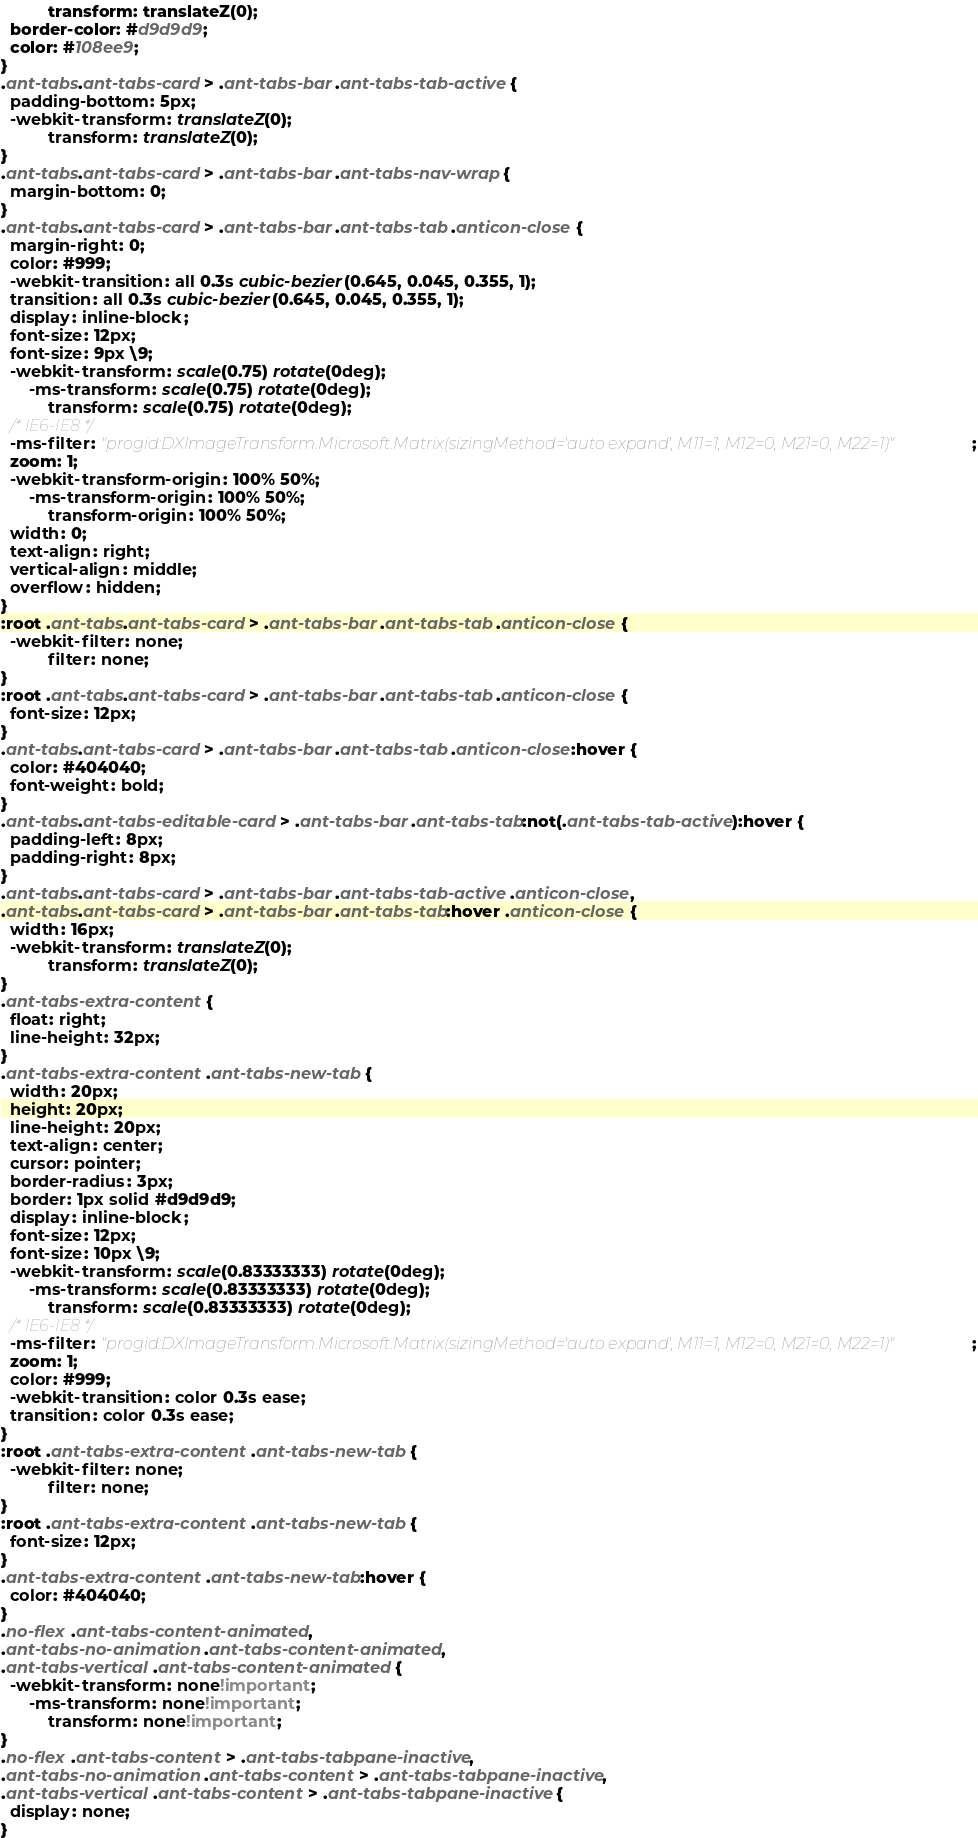Convert code to text. <code><loc_0><loc_0><loc_500><loc_500><_CSS_>          transform: translateZ(0);
  border-color: #d9d9d9;
  color: #108ee9;
}
.ant-tabs.ant-tabs-card > .ant-tabs-bar .ant-tabs-tab-active {
  padding-bottom: 5px;
  -webkit-transform: translateZ(0);
          transform: translateZ(0);
}
.ant-tabs.ant-tabs-card > .ant-tabs-bar .ant-tabs-nav-wrap {
  margin-bottom: 0;
}
.ant-tabs.ant-tabs-card > .ant-tabs-bar .ant-tabs-tab .anticon-close {
  margin-right: 0;
  color: #999;
  -webkit-transition: all 0.3s cubic-bezier(0.645, 0.045, 0.355, 1);
  transition: all 0.3s cubic-bezier(0.645, 0.045, 0.355, 1);
  display: inline-block;
  font-size: 12px;
  font-size: 9px \9;
  -webkit-transform: scale(0.75) rotate(0deg);
      -ms-transform: scale(0.75) rotate(0deg);
          transform: scale(0.75) rotate(0deg);
  /* IE6-IE8 */
  -ms-filter: "progid:DXImageTransform.Microsoft.Matrix(sizingMethod='auto expand', M11=1, M12=0, M21=0, M22=1)";
  zoom: 1;
  -webkit-transform-origin: 100% 50%;
      -ms-transform-origin: 100% 50%;
          transform-origin: 100% 50%;
  width: 0;
  text-align: right;
  vertical-align: middle;
  overflow: hidden;
}
:root .ant-tabs.ant-tabs-card > .ant-tabs-bar .ant-tabs-tab .anticon-close {
  -webkit-filter: none;
          filter: none;
}
:root .ant-tabs.ant-tabs-card > .ant-tabs-bar .ant-tabs-tab .anticon-close {
  font-size: 12px;
}
.ant-tabs.ant-tabs-card > .ant-tabs-bar .ant-tabs-tab .anticon-close:hover {
  color: #404040;
  font-weight: bold;
}
.ant-tabs.ant-tabs-editable-card > .ant-tabs-bar .ant-tabs-tab:not(.ant-tabs-tab-active):hover {
  padding-left: 8px;
  padding-right: 8px;
}
.ant-tabs.ant-tabs-card > .ant-tabs-bar .ant-tabs-tab-active .anticon-close,
.ant-tabs.ant-tabs-card > .ant-tabs-bar .ant-tabs-tab:hover .anticon-close {
  width: 16px;
  -webkit-transform: translateZ(0);
          transform: translateZ(0);
}
.ant-tabs-extra-content {
  float: right;
  line-height: 32px;
}
.ant-tabs-extra-content .ant-tabs-new-tab {
  width: 20px;
  height: 20px;
  line-height: 20px;
  text-align: center;
  cursor: pointer;
  border-radius: 3px;
  border: 1px solid #d9d9d9;
  display: inline-block;
  font-size: 12px;
  font-size: 10px \9;
  -webkit-transform: scale(0.83333333) rotate(0deg);
      -ms-transform: scale(0.83333333) rotate(0deg);
          transform: scale(0.83333333) rotate(0deg);
  /* IE6-IE8 */
  -ms-filter: "progid:DXImageTransform.Microsoft.Matrix(sizingMethod='auto expand', M11=1, M12=0, M21=0, M22=1)";
  zoom: 1;
  color: #999;
  -webkit-transition: color 0.3s ease;
  transition: color 0.3s ease;
}
:root .ant-tabs-extra-content .ant-tabs-new-tab {
  -webkit-filter: none;
          filter: none;
}
:root .ant-tabs-extra-content .ant-tabs-new-tab {
  font-size: 12px;
}
.ant-tabs-extra-content .ant-tabs-new-tab:hover {
  color: #404040;
}
.no-flex .ant-tabs-content-animated,
.ant-tabs-no-animation .ant-tabs-content-animated,
.ant-tabs-vertical .ant-tabs-content-animated {
  -webkit-transform: none!important;
      -ms-transform: none!important;
          transform: none!important;
}
.no-flex .ant-tabs-content > .ant-tabs-tabpane-inactive,
.ant-tabs-no-animation .ant-tabs-content > .ant-tabs-tabpane-inactive,
.ant-tabs-vertical .ant-tabs-content > .ant-tabs-tabpane-inactive {
  display: none;
}
</code> 